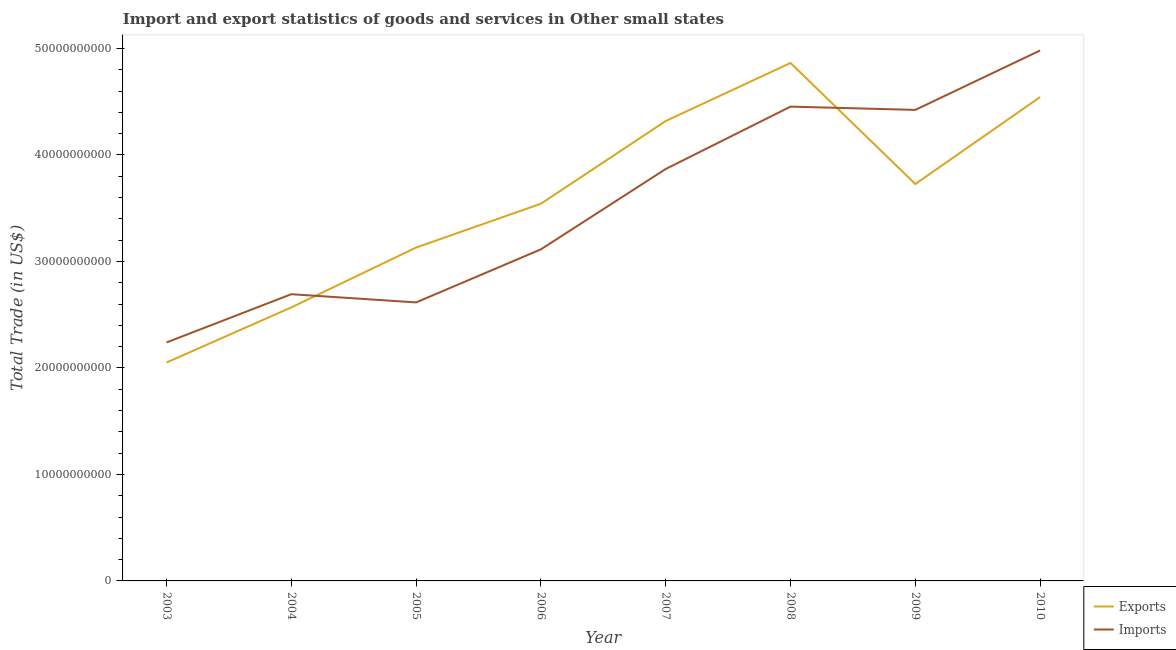How many different coloured lines are there?
Give a very brief answer. 2. Does the line corresponding to imports of goods and services intersect with the line corresponding to export of goods and services?
Your answer should be compact. Yes. What is the export of goods and services in 2006?
Your answer should be very brief. 3.54e+1. Across all years, what is the maximum imports of goods and services?
Provide a succinct answer. 4.98e+1. Across all years, what is the minimum export of goods and services?
Your answer should be compact. 2.05e+1. In which year was the imports of goods and services maximum?
Make the answer very short. 2010. In which year was the imports of goods and services minimum?
Give a very brief answer. 2003. What is the total imports of goods and services in the graph?
Provide a short and direct response. 2.84e+11. What is the difference between the imports of goods and services in 2006 and that in 2007?
Make the answer very short. -7.54e+09. What is the difference between the imports of goods and services in 2004 and the export of goods and services in 2006?
Your response must be concise. -8.50e+09. What is the average export of goods and services per year?
Make the answer very short. 3.59e+1. In the year 2008, what is the difference between the export of goods and services and imports of goods and services?
Your answer should be compact. 4.10e+09. What is the ratio of the export of goods and services in 2008 to that in 2010?
Your answer should be very brief. 1.07. Is the export of goods and services in 2003 less than that in 2010?
Offer a terse response. Yes. What is the difference between the highest and the second highest export of goods and services?
Your answer should be very brief. 3.20e+09. What is the difference between the highest and the lowest imports of goods and services?
Your answer should be very brief. 2.74e+1. In how many years, is the imports of goods and services greater than the average imports of goods and services taken over all years?
Provide a short and direct response. 4. Is the sum of the imports of goods and services in 2004 and 2009 greater than the maximum export of goods and services across all years?
Give a very brief answer. Yes. How many lines are there?
Make the answer very short. 2. How many years are there in the graph?
Provide a succinct answer. 8. Does the graph contain any zero values?
Keep it short and to the point. No. Where does the legend appear in the graph?
Offer a terse response. Bottom right. How are the legend labels stacked?
Keep it short and to the point. Vertical. What is the title of the graph?
Your answer should be compact. Import and export statistics of goods and services in Other small states. Does "Net National savings" appear as one of the legend labels in the graph?
Make the answer very short. No. What is the label or title of the Y-axis?
Provide a succinct answer. Total Trade (in US$). What is the Total Trade (in US$) in Exports in 2003?
Give a very brief answer. 2.05e+1. What is the Total Trade (in US$) of Imports in 2003?
Your response must be concise. 2.24e+1. What is the Total Trade (in US$) of Exports in 2004?
Ensure brevity in your answer.  2.57e+1. What is the Total Trade (in US$) of Imports in 2004?
Provide a succinct answer. 2.69e+1. What is the Total Trade (in US$) of Exports in 2005?
Your response must be concise. 3.13e+1. What is the Total Trade (in US$) in Imports in 2005?
Offer a very short reply. 2.62e+1. What is the Total Trade (in US$) of Exports in 2006?
Make the answer very short. 3.54e+1. What is the Total Trade (in US$) in Imports in 2006?
Keep it short and to the point. 3.11e+1. What is the Total Trade (in US$) in Exports in 2007?
Provide a short and direct response. 4.32e+1. What is the Total Trade (in US$) of Imports in 2007?
Provide a succinct answer. 3.87e+1. What is the Total Trade (in US$) of Exports in 2008?
Offer a very short reply. 4.86e+1. What is the Total Trade (in US$) in Imports in 2008?
Provide a succinct answer. 4.45e+1. What is the Total Trade (in US$) of Exports in 2009?
Provide a short and direct response. 3.73e+1. What is the Total Trade (in US$) of Imports in 2009?
Ensure brevity in your answer.  4.42e+1. What is the Total Trade (in US$) of Exports in 2010?
Provide a succinct answer. 4.54e+1. What is the Total Trade (in US$) in Imports in 2010?
Provide a short and direct response. 4.98e+1. Across all years, what is the maximum Total Trade (in US$) of Exports?
Give a very brief answer. 4.86e+1. Across all years, what is the maximum Total Trade (in US$) of Imports?
Your answer should be compact. 4.98e+1. Across all years, what is the minimum Total Trade (in US$) of Exports?
Provide a succinct answer. 2.05e+1. Across all years, what is the minimum Total Trade (in US$) in Imports?
Ensure brevity in your answer.  2.24e+1. What is the total Total Trade (in US$) of Exports in the graph?
Your answer should be compact. 2.87e+11. What is the total Total Trade (in US$) of Imports in the graph?
Your response must be concise. 2.84e+11. What is the difference between the Total Trade (in US$) of Exports in 2003 and that in 2004?
Your response must be concise. -5.17e+09. What is the difference between the Total Trade (in US$) in Imports in 2003 and that in 2004?
Keep it short and to the point. -4.53e+09. What is the difference between the Total Trade (in US$) in Exports in 2003 and that in 2005?
Make the answer very short. -1.08e+1. What is the difference between the Total Trade (in US$) of Imports in 2003 and that in 2005?
Your response must be concise. -3.76e+09. What is the difference between the Total Trade (in US$) in Exports in 2003 and that in 2006?
Offer a terse response. -1.49e+1. What is the difference between the Total Trade (in US$) of Imports in 2003 and that in 2006?
Ensure brevity in your answer.  -8.75e+09. What is the difference between the Total Trade (in US$) in Exports in 2003 and that in 2007?
Make the answer very short. -2.27e+1. What is the difference between the Total Trade (in US$) in Imports in 2003 and that in 2007?
Your answer should be very brief. -1.63e+1. What is the difference between the Total Trade (in US$) of Exports in 2003 and that in 2008?
Provide a short and direct response. -2.81e+1. What is the difference between the Total Trade (in US$) in Imports in 2003 and that in 2008?
Make the answer very short. -2.21e+1. What is the difference between the Total Trade (in US$) in Exports in 2003 and that in 2009?
Your answer should be compact. -1.68e+1. What is the difference between the Total Trade (in US$) in Imports in 2003 and that in 2009?
Make the answer very short. -2.18e+1. What is the difference between the Total Trade (in US$) in Exports in 2003 and that in 2010?
Ensure brevity in your answer.  -2.49e+1. What is the difference between the Total Trade (in US$) in Imports in 2003 and that in 2010?
Your response must be concise. -2.74e+1. What is the difference between the Total Trade (in US$) of Exports in 2004 and that in 2005?
Ensure brevity in your answer.  -5.62e+09. What is the difference between the Total Trade (in US$) in Imports in 2004 and that in 2005?
Give a very brief answer. 7.72e+08. What is the difference between the Total Trade (in US$) of Exports in 2004 and that in 2006?
Provide a succinct answer. -9.74e+09. What is the difference between the Total Trade (in US$) in Imports in 2004 and that in 2006?
Ensure brevity in your answer.  -4.21e+09. What is the difference between the Total Trade (in US$) of Exports in 2004 and that in 2007?
Provide a short and direct response. -1.75e+1. What is the difference between the Total Trade (in US$) of Imports in 2004 and that in 2007?
Your response must be concise. -1.18e+1. What is the difference between the Total Trade (in US$) of Exports in 2004 and that in 2008?
Ensure brevity in your answer.  -2.30e+1. What is the difference between the Total Trade (in US$) in Imports in 2004 and that in 2008?
Give a very brief answer. -1.76e+1. What is the difference between the Total Trade (in US$) in Exports in 2004 and that in 2009?
Provide a short and direct response. -1.16e+1. What is the difference between the Total Trade (in US$) of Imports in 2004 and that in 2009?
Keep it short and to the point. -1.73e+1. What is the difference between the Total Trade (in US$) of Exports in 2004 and that in 2010?
Your answer should be compact. -1.98e+1. What is the difference between the Total Trade (in US$) in Imports in 2004 and that in 2010?
Your response must be concise. -2.29e+1. What is the difference between the Total Trade (in US$) of Exports in 2005 and that in 2006?
Ensure brevity in your answer.  -4.12e+09. What is the difference between the Total Trade (in US$) of Imports in 2005 and that in 2006?
Give a very brief answer. -4.99e+09. What is the difference between the Total Trade (in US$) of Exports in 2005 and that in 2007?
Offer a very short reply. -1.19e+1. What is the difference between the Total Trade (in US$) in Imports in 2005 and that in 2007?
Offer a very short reply. -1.25e+1. What is the difference between the Total Trade (in US$) in Exports in 2005 and that in 2008?
Give a very brief answer. -1.73e+1. What is the difference between the Total Trade (in US$) in Imports in 2005 and that in 2008?
Offer a very short reply. -1.84e+1. What is the difference between the Total Trade (in US$) of Exports in 2005 and that in 2009?
Your response must be concise. -5.97e+09. What is the difference between the Total Trade (in US$) in Imports in 2005 and that in 2009?
Your answer should be compact. -1.81e+1. What is the difference between the Total Trade (in US$) of Exports in 2005 and that in 2010?
Provide a succinct answer. -1.41e+1. What is the difference between the Total Trade (in US$) of Imports in 2005 and that in 2010?
Give a very brief answer. -2.37e+1. What is the difference between the Total Trade (in US$) of Exports in 2006 and that in 2007?
Give a very brief answer. -7.77e+09. What is the difference between the Total Trade (in US$) in Imports in 2006 and that in 2007?
Ensure brevity in your answer.  -7.54e+09. What is the difference between the Total Trade (in US$) of Exports in 2006 and that in 2008?
Offer a terse response. -1.32e+1. What is the difference between the Total Trade (in US$) in Imports in 2006 and that in 2008?
Your answer should be very brief. -1.34e+1. What is the difference between the Total Trade (in US$) in Exports in 2006 and that in 2009?
Make the answer very short. -1.85e+09. What is the difference between the Total Trade (in US$) in Imports in 2006 and that in 2009?
Keep it short and to the point. -1.31e+1. What is the difference between the Total Trade (in US$) in Exports in 2006 and that in 2010?
Make the answer very short. -1.00e+1. What is the difference between the Total Trade (in US$) of Imports in 2006 and that in 2010?
Offer a very short reply. -1.87e+1. What is the difference between the Total Trade (in US$) of Exports in 2007 and that in 2008?
Your answer should be very brief. -5.45e+09. What is the difference between the Total Trade (in US$) of Imports in 2007 and that in 2008?
Provide a succinct answer. -5.86e+09. What is the difference between the Total Trade (in US$) in Exports in 2007 and that in 2009?
Your answer should be very brief. 5.92e+09. What is the difference between the Total Trade (in US$) of Imports in 2007 and that in 2009?
Provide a short and direct response. -5.55e+09. What is the difference between the Total Trade (in US$) in Exports in 2007 and that in 2010?
Make the answer very short. -2.25e+09. What is the difference between the Total Trade (in US$) of Imports in 2007 and that in 2010?
Offer a very short reply. -1.11e+1. What is the difference between the Total Trade (in US$) in Exports in 2008 and that in 2009?
Keep it short and to the point. 1.14e+1. What is the difference between the Total Trade (in US$) of Imports in 2008 and that in 2009?
Offer a very short reply. 3.06e+08. What is the difference between the Total Trade (in US$) of Exports in 2008 and that in 2010?
Your answer should be compact. 3.20e+09. What is the difference between the Total Trade (in US$) of Imports in 2008 and that in 2010?
Keep it short and to the point. -5.27e+09. What is the difference between the Total Trade (in US$) in Exports in 2009 and that in 2010?
Your response must be concise. -8.17e+09. What is the difference between the Total Trade (in US$) of Imports in 2009 and that in 2010?
Offer a terse response. -5.58e+09. What is the difference between the Total Trade (in US$) in Exports in 2003 and the Total Trade (in US$) in Imports in 2004?
Ensure brevity in your answer.  -6.41e+09. What is the difference between the Total Trade (in US$) of Exports in 2003 and the Total Trade (in US$) of Imports in 2005?
Your answer should be compact. -5.64e+09. What is the difference between the Total Trade (in US$) in Exports in 2003 and the Total Trade (in US$) in Imports in 2006?
Offer a terse response. -1.06e+1. What is the difference between the Total Trade (in US$) in Exports in 2003 and the Total Trade (in US$) in Imports in 2007?
Keep it short and to the point. -1.82e+1. What is the difference between the Total Trade (in US$) in Exports in 2003 and the Total Trade (in US$) in Imports in 2008?
Keep it short and to the point. -2.40e+1. What is the difference between the Total Trade (in US$) of Exports in 2003 and the Total Trade (in US$) of Imports in 2009?
Keep it short and to the point. -2.37e+1. What is the difference between the Total Trade (in US$) of Exports in 2003 and the Total Trade (in US$) of Imports in 2010?
Offer a terse response. -2.93e+1. What is the difference between the Total Trade (in US$) in Exports in 2004 and the Total Trade (in US$) in Imports in 2005?
Make the answer very short. -4.68e+08. What is the difference between the Total Trade (in US$) in Exports in 2004 and the Total Trade (in US$) in Imports in 2006?
Make the answer very short. -5.45e+09. What is the difference between the Total Trade (in US$) in Exports in 2004 and the Total Trade (in US$) in Imports in 2007?
Your answer should be very brief. -1.30e+1. What is the difference between the Total Trade (in US$) of Exports in 2004 and the Total Trade (in US$) of Imports in 2008?
Your response must be concise. -1.89e+1. What is the difference between the Total Trade (in US$) of Exports in 2004 and the Total Trade (in US$) of Imports in 2009?
Offer a terse response. -1.85e+1. What is the difference between the Total Trade (in US$) in Exports in 2004 and the Total Trade (in US$) in Imports in 2010?
Offer a terse response. -2.41e+1. What is the difference between the Total Trade (in US$) of Exports in 2005 and the Total Trade (in US$) of Imports in 2006?
Your response must be concise. 1.66e+08. What is the difference between the Total Trade (in US$) of Exports in 2005 and the Total Trade (in US$) of Imports in 2007?
Make the answer very short. -7.38e+09. What is the difference between the Total Trade (in US$) in Exports in 2005 and the Total Trade (in US$) in Imports in 2008?
Give a very brief answer. -1.32e+1. What is the difference between the Total Trade (in US$) in Exports in 2005 and the Total Trade (in US$) in Imports in 2009?
Give a very brief answer. -1.29e+1. What is the difference between the Total Trade (in US$) of Exports in 2005 and the Total Trade (in US$) of Imports in 2010?
Give a very brief answer. -1.85e+1. What is the difference between the Total Trade (in US$) of Exports in 2006 and the Total Trade (in US$) of Imports in 2007?
Your answer should be very brief. -3.26e+09. What is the difference between the Total Trade (in US$) of Exports in 2006 and the Total Trade (in US$) of Imports in 2008?
Make the answer very short. -9.12e+09. What is the difference between the Total Trade (in US$) of Exports in 2006 and the Total Trade (in US$) of Imports in 2009?
Offer a very short reply. -8.81e+09. What is the difference between the Total Trade (in US$) in Exports in 2006 and the Total Trade (in US$) in Imports in 2010?
Ensure brevity in your answer.  -1.44e+1. What is the difference between the Total Trade (in US$) in Exports in 2007 and the Total Trade (in US$) in Imports in 2008?
Provide a succinct answer. -1.35e+09. What is the difference between the Total Trade (in US$) in Exports in 2007 and the Total Trade (in US$) in Imports in 2009?
Make the answer very short. -1.04e+09. What is the difference between the Total Trade (in US$) of Exports in 2007 and the Total Trade (in US$) of Imports in 2010?
Offer a very short reply. -6.62e+09. What is the difference between the Total Trade (in US$) of Exports in 2008 and the Total Trade (in US$) of Imports in 2009?
Your answer should be very brief. 4.41e+09. What is the difference between the Total Trade (in US$) of Exports in 2008 and the Total Trade (in US$) of Imports in 2010?
Your answer should be very brief. -1.17e+09. What is the difference between the Total Trade (in US$) of Exports in 2009 and the Total Trade (in US$) of Imports in 2010?
Provide a succinct answer. -1.25e+1. What is the average Total Trade (in US$) of Exports per year?
Keep it short and to the point. 3.59e+1. What is the average Total Trade (in US$) of Imports per year?
Provide a succinct answer. 3.55e+1. In the year 2003, what is the difference between the Total Trade (in US$) of Exports and Total Trade (in US$) of Imports?
Offer a terse response. -1.88e+09. In the year 2004, what is the difference between the Total Trade (in US$) in Exports and Total Trade (in US$) in Imports?
Make the answer very short. -1.24e+09. In the year 2005, what is the difference between the Total Trade (in US$) in Exports and Total Trade (in US$) in Imports?
Provide a short and direct response. 5.15e+09. In the year 2006, what is the difference between the Total Trade (in US$) in Exports and Total Trade (in US$) in Imports?
Your response must be concise. 4.28e+09. In the year 2007, what is the difference between the Total Trade (in US$) in Exports and Total Trade (in US$) in Imports?
Offer a terse response. 4.51e+09. In the year 2008, what is the difference between the Total Trade (in US$) in Exports and Total Trade (in US$) in Imports?
Ensure brevity in your answer.  4.10e+09. In the year 2009, what is the difference between the Total Trade (in US$) of Exports and Total Trade (in US$) of Imports?
Give a very brief answer. -6.96e+09. In the year 2010, what is the difference between the Total Trade (in US$) of Exports and Total Trade (in US$) of Imports?
Keep it short and to the point. -4.37e+09. What is the ratio of the Total Trade (in US$) in Exports in 2003 to that in 2004?
Ensure brevity in your answer.  0.8. What is the ratio of the Total Trade (in US$) of Imports in 2003 to that in 2004?
Provide a succinct answer. 0.83. What is the ratio of the Total Trade (in US$) in Exports in 2003 to that in 2005?
Give a very brief answer. 0.66. What is the ratio of the Total Trade (in US$) of Imports in 2003 to that in 2005?
Provide a succinct answer. 0.86. What is the ratio of the Total Trade (in US$) of Exports in 2003 to that in 2006?
Provide a succinct answer. 0.58. What is the ratio of the Total Trade (in US$) in Imports in 2003 to that in 2006?
Your response must be concise. 0.72. What is the ratio of the Total Trade (in US$) of Exports in 2003 to that in 2007?
Your answer should be compact. 0.47. What is the ratio of the Total Trade (in US$) in Imports in 2003 to that in 2007?
Your answer should be very brief. 0.58. What is the ratio of the Total Trade (in US$) of Exports in 2003 to that in 2008?
Provide a short and direct response. 0.42. What is the ratio of the Total Trade (in US$) of Imports in 2003 to that in 2008?
Your answer should be compact. 0.5. What is the ratio of the Total Trade (in US$) of Exports in 2003 to that in 2009?
Provide a short and direct response. 0.55. What is the ratio of the Total Trade (in US$) in Imports in 2003 to that in 2009?
Your answer should be very brief. 0.51. What is the ratio of the Total Trade (in US$) in Exports in 2003 to that in 2010?
Offer a very short reply. 0.45. What is the ratio of the Total Trade (in US$) in Imports in 2003 to that in 2010?
Keep it short and to the point. 0.45. What is the ratio of the Total Trade (in US$) of Exports in 2004 to that in 2005?
Ensure brevity in your answer.  0.82. What is the ratio of the Total Trade (in US$) in Imports in 2004 to that in 2005?
Your answer should be compact. 1.03. What is the ratio of the Total Trade (in US$) of Exports in 2004 to that in 2006?
Offer a terse response. 0.73. What is the ratio of the Total Trade (in US$) in Imports in 2004 to that in 2006?
Your answer should be very brief. 0.86. What is the ratio of the Total Trade (in US$) in Exports in 2004 to that in 2007?
Offer a very short reply. 0.59. What is the ratio of the Total Trade (in US$) of Imports in 2004 to that in 2007?
Give a very brief answer. 0.7. What is the ratio of the Total Trade (in US$) of Exports in 2004 to that in 2008?
Keep it short and to the point. 0.53. What is the ratio of the Total Trade (in US$) in Imports in 2004 to that in 2008?
Offer a very short reply. 0.6. What is the ratio of the Total Trade (in US$) of Exports in 2004 to that in 2009?
Offer a terse response. 0.69. What is the ratio of the Total Trade (in US$) of Imports in 2004 to that in 2009?
Your answer should be very brief. 0.61. What is the ratio of the Total Trade (in US$) in Exports in 2004 to that in 2010?
Offer a very short reply. 0.57. What is the ratio of the Total Trade (in US$) in Imports in 2004 to that in 2010?
Offer a terse response. 0.54. What is the ratio of the Total Trade (in US$) of Exports in 2005 to that in 2006?
Your answer should be very brief. 0.88. What is the ratio of the Total Trade (in US$) in Imports in 2005 to that in 2006?
Offer a terse response. 0.84. What is the ratio of the Total Trade (in US$) of Exports in 2005 to that in 2007?
Your response must be concise. 0.72. What is the ratio of the Total Trade (in US$) of Imports in 2005 to that in 2007?
Provide a short and direct response. 0.68. What is the ratio of the Total Trade (in US$) in Exports in 2005 to that in 2008?
Give a very brief answer. 0.64. What is the ratio of the Total Trade (in US$) of Imports in 2005 to that in 2008?
Provide a short and direct response. 0.59. What is the ratio of the Total Trade (in US$) of Exports in 2005 to that in 2009?
Make the answer very short. 0.84. What is the ratio of the Total Trade (in US$) in Imports in 2005 to that in 2009?
Provide a succinct answer. 0.59. What is the ratio of the Total Trade (in US$) of Exports in 2005 to that in 2010?
Your response must be concise. 0.69. What is the ratio of the Total Trade (in US$) in Imports in 2005 to that in 2010?
Your answer should be very brief. 0.53. What is the ratio of the Total Trade (in US$) of Exports in 2006 to that in 2007?
Provide a short and direct response. 0.82. What is the ratio of the Total Trade (in US$) in Imports in 2006 to that in 2007?
Provide a succinct answer. 0.81. What is the ratio of the Total Trade (in US$) in Exports in 2006 to that in 2008?
Your answer should be very brief. 0.73. What is the ratio of the Total Trade (in US$) in Imports in 2006 to that in 2008?
Make the answer very short. 0.7. What is the ratio of the Total Trade (in US$) in Exports in 2006 to that in 2009?
Ensure brevity in your answer.  0.95. What is the ratio of the Total Trade (in US$) of Imports in 2006 to that in 2009?
Your response must be concise. 0.7. What is the ratio of the Total Trade (in US$) of Exports in 2006 to that in 2010?
Keep it short and to the point. 0.78. What is the ratio of the Total Trade (in US$) in Imports in 2006 to that in 2010?
Your answer should be compact. 0.63. What is the ratio of the Total Trade (in US$) of Exports in 2007 to that in 2008?
Provide a short and direct response. 0.89. What is the ratio of the Total Trade (in US$) in Imports in 2007 to that in 2008?
Your answer should be very brief. 0.87. What is the ratio of the Total Trade (in US$) in Exports in 2007 to that in 2009?
Make the answer very short. 1.16. What is the ratio of the Total Trade (in US$) of Imports in 2007 to that in 2009?
Ensure brevity in your answer.  0.87. What is the ratio of the Total Trade (in US$) of Exports in 2007 to that in 2010?
Give a very brief answer. 0.95. What is the ratio of the Total Trade (in US$) in Imports in 2007 to that in 2010?
Make the answer very short. 0.78. What is the ratio of the Total Trade (in US$) in Exports in 2008 to that in 2009?
Give a very brief answer. 1.3. What is the ratio of the Total Trade (in US$) of Imports in 2008 to that in 2009?
Offer a very short reply. 1.01. What is the ratio of the Total Trade (in US$) in Exports in 2008 to that in 2010?
Keep it short and to the point. 1.07. What is the ratio of the Total Trade (in US$) of Imports in 2008 to that in 2010?
Offer a very short reply. 0.89. What is the ratio of the Total Trade (in US$) in Exports in 2009 to that in 2010?
Give a very brief answer. 0.82. What is the ratio of the Total Trade (in US$) in Imports in 2009 to that in 2010?
Your answer should be compact. 0.89. What is the difference between the highest and the second highest Total Trade (in US$) of Exports?
Provide a short and direct response. 3.20e+09. What is the difference between the highest and the second highest Total Trade (in US$) of Imports?
Ensure brevity in your answer.  5.27e+09. What is the difference between the highest and the lowest Total Trade (in US$) in Exports?
Offer a very short reply. 2.81e+1. What is the difference between the highest and the lowest Total Trade (in US$) in Imports?
Ensure brevity in your answer.  2.74e+1. 